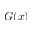<formula> <loc_0><loc_0><loc_500><loc_500>G ( x )</formula> 